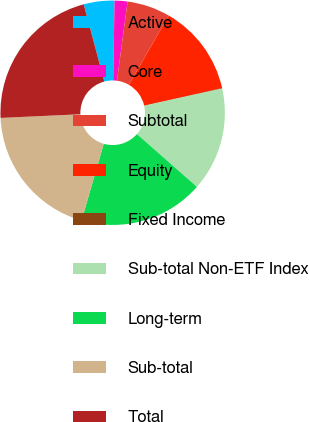Convert chart to OTSL. <chart><loc_0><loc_0><loc_500><loc_500><pie_chart><fcel>Active<fcel>Core<fcel>Subtotal<fcel>Equity<fcel>Fixed Income<fcel>Sub-total Non-ETF Index<fcel>Long-term<fcel>Sub-total<fcel>Total<nl><fcel>4.42%<fcel>1.86%<fcel>6.21%<fcel>13.14%<fcel>0.07%<fcel>14.93%<fcel>17.99%<fcel>19.79%<fcel>21.58%<nl></chart> 